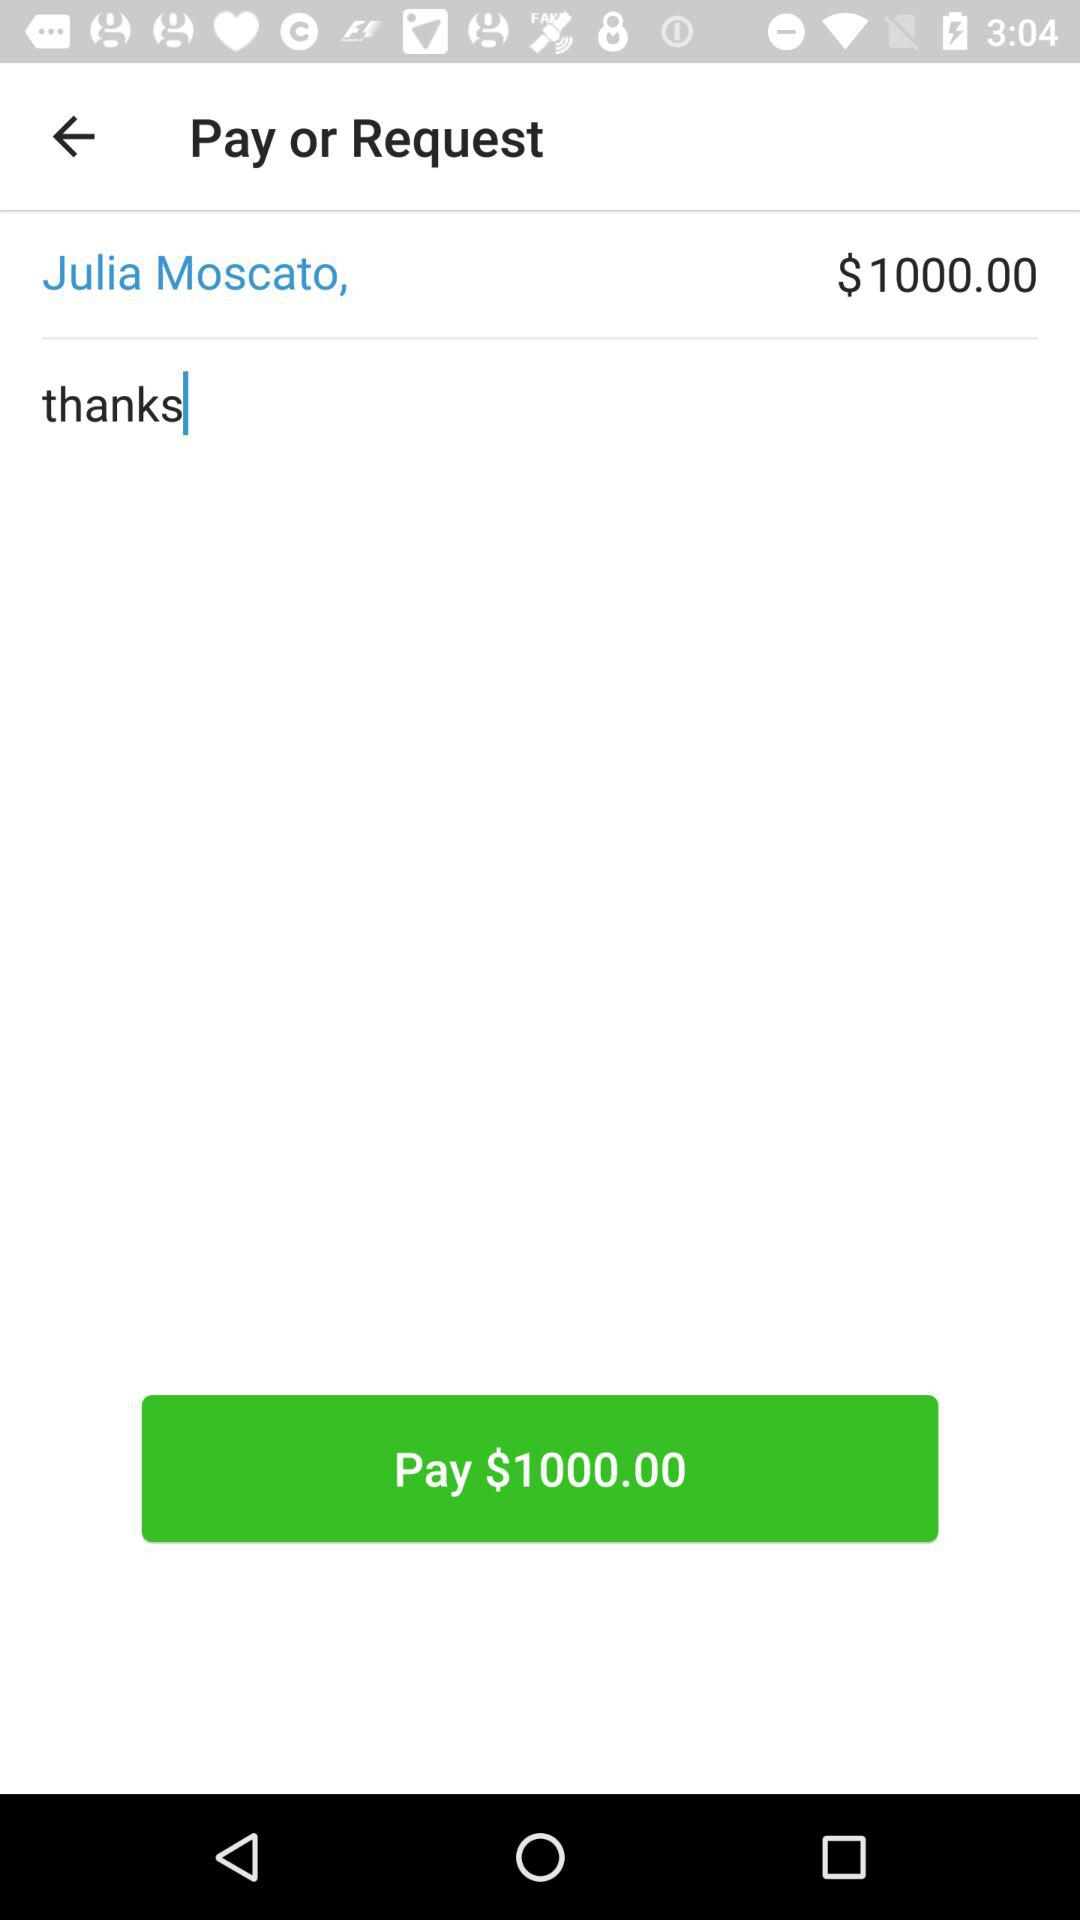How many dollars do I have to pay Julia Moscato? You have to pay Julia Moscato $1000.00. 